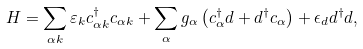<formula> <loc_0><loc_0><loc_500><loc_500>H = \sum _ { \alpha { k } } \varepsilon _ { k } c ^ { \dag } _ { \alpha { k } } c _ { \alpha { k } } + \sum _ { \alpha } g _ { \alpha } \left ( c ^ { \dagger } _ { \alpha } d + d ^ { \dagger } c _ { \alpha } \right ) + \epsilon _ { d } d ^ { \dagger } d ,</formula> 